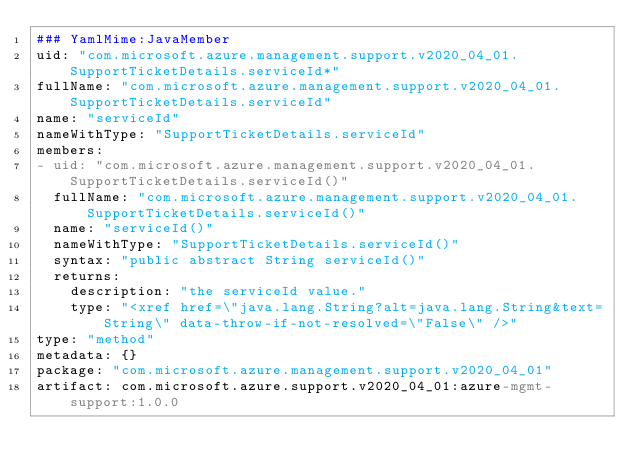Convert code to text. <code><loc_0><loc_0><loc_500><loc_500><_YAML_>### YamlMime:JavaMember
uid: "com.microsoft.azure.management.support.v2020_04_01.SupportTicketDetails.serviceId*"
fullName: "com.microsoft.azure.management.support.v2020_04_01.SupportTicketDetails.serviceId"
name: "serviceId"
nameWithType: "SupportTicketDetails.serviceId"
members:
- uid: "com.microsoft.azure.management.support.v2020_04_01.SupportTicketDetails.serviceId()"
  fullName: "com.microsoft.azure.management.support.v2020_04_01.SupportTicketDetails.serviceId()"
  name: "serviceId()"
  nameWithType: "SupportTicketDetails.serviceId()"
  syntax: "public abstract String serviceId()"
  returns:
    description: "the serviceId value."
    type: "<xref href=\"java.lang.String?alt=java.lang.String&text=String\" data-throw-if-not-resolved=\"False\" />"
type: "method"
metadata: {}
package: "com.microsoft.azure.management.support.v2020_04_01"
artifact: com.microsoft.azure.support.v2020_04_01:azure-mgmt-support:1.0.0
</code> 